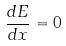<formula> <loc_0><loc_0><loc_500><loc_500>\frac { d E } { d x } = 0</formula> 